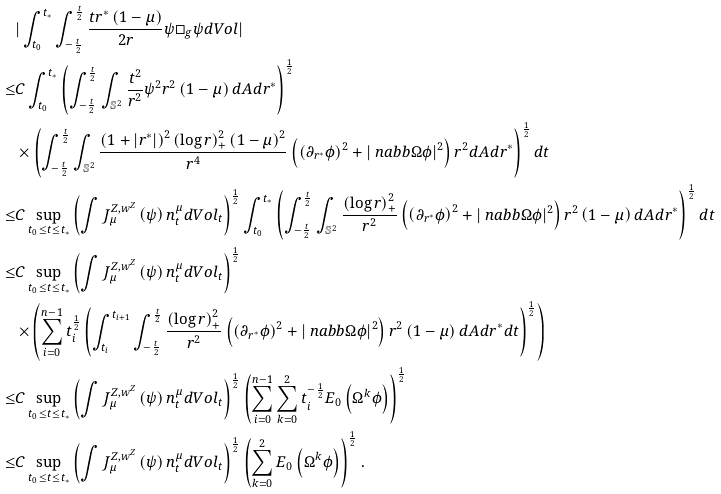<formula> <loc_0><loc_0><loc_500><loc_500>& | \int _ { t _ { 0 } } ^ { t _ { * } } \int _ { - \frac { t } { 2 } } ^ { \frac { t } { 2 } } \frac { t r ^ { * } \left ( 1 - \mu \right ) } { 2 r } \psi \Box _ { g } \psi d V o l | \\ \leq & C \int _ { t _ { 0 } } ^ { t _ { * } } \left ( \int _ { - \frac { t } { 2 } } ^ { \frac { t } { 2 } } \int _ { \mathbb { S } ^ { 2 } } \frac { t ^ { 2 } } { r ^ { 2 } } \psi ^ { 2 } r ^ { 2 } \left ( 1 - \mu \right ) d A d r ^ { * } \right ) ^ { \frac { 1 } { 2 } } \\ & \times \left ( \int _ { - \frac { t } { 2 } } ^ { \frac { t } { 2 } } \int _ { \mathbb { S } ^ { 2 } } \frac { \left ( 1 + | r ^ { * } | \right ) ^ { 2 } \left ( \log r \right ) _ { + } ^ { 2 } \left ( 1 - \mu \right ) ^ { 2 } } { r ^ { 4 } } \left ( \left ( \partial _ { r ^ { * } } \phi \right ) ^ { 2 } + | \ n a b b \Omega \phi | ^ { 2 } \right ) r ^ { 2 } d A d r ^ { * } \right ) ^ { \frac { 1 } { 2 } } d t \\ \leq & C \sup _ { t _ { 0 } \leq t \leq t _ { * } } \left ( \int J ^ { Z , w ^ { Z } } _ { \mu } \left ( \psi \right ) n _ { t } ^ { \mu } d V o l _ { t } \right ) ^ { \frac { 1 } { 2 } } \int _ { t _ { 0 } } ^ { t _ { * } } \left ( \int _ { - \frac { t } { 2 } } ^ { \frac { t } { 2 } } \int _ { \mathbb { S } ^ { 2 } } \frac { \left ( \log r \right ) _ { + } ^ { 2 } } { r ^ { 2 } } \left ( \left ( \partial _ { r ^ { * } } \phi \right ) ^ { 2 } + | \ n a b b \Omega \phi | ^ { 2 } \right ) r ^ { 2 } \left ( 1 - \mu \right ) d A d r ^ { * } \right ) ^ { \frac { 1 } { 2 } } d t \\ \leq & C \sup _ { t _ { 0 } \leq t \leq t _ { * } } \left ( \int J ^ { Z , w ^ { Z } } _ { \mu } \left ( \psi \right ) n _ { t } ^ { \mu } d V o l _ { t } \right ) ^ { \frac { 1 } { 2 } } \\ & \times \left ( \sum _ { i = 0 } ^ { n - 1 } t _ { i } ^ { \frac { 1 } { 2 } } \left ( \int _ { t _ { i } } ^ { t _ { i + 1 } } \int _ { - \frac { t } { 2 } } ^ { \frac { t } { 2 } } \frac { \left ( \log r \right ) _ { + } ^ { 2 } } { r ^ { 2 } } \left ( \left ( \partial _ { r ^ { * } } \phi \right ) ^ { 2 } + | \ n a b b \Omega \phi | ^ { 2 } \right ) r ^ { 2 } \left ( 1 - \mu \right ) d A d r ^ { * } d t \right ) ^ { \frac { 1 } { 2 } } \right ) \\ \leq & C \sup _ { t _ { 0 } \leq t \leq t _ { * } } \left ( \int J ^ { Z , w ^ { Z } } _ { \mu } \left ( \psi \right ) n _ { t } ^ { \mu } d V o l _ { t } \right ) ^ { \frac { 1 } { 2 } } \left ( \sum _ { i = 0 } ^ { n - 1 } \sum _ { k = 0 } ^ { 2 } t _ { i } ^ { - \frac { 1 } { 2 } } E _ { 0 } \left ( \Omega ^ { k } \phi \right ) \right ) ^ { \frac { 1 } { 2 } } \\ \leq & C \sup _ { t _ { 0 } \leq t \leq t _ { * } } \left ( \int J ^ { Z , w ^ { Z } } _ { \mu } \left ( \psi \right ) n _ { t } ^ { \mu } d V o l _ { t } \right ) ^ { \frac { 1 } { 2 } } \left ( \sum _ { k = 0 } ^ { 2 } E _ { 0 } \left ( \Omega ^ { k } \phi \right ) \right ) ^ { \frac { 1 } { 2 } } .</formula> 